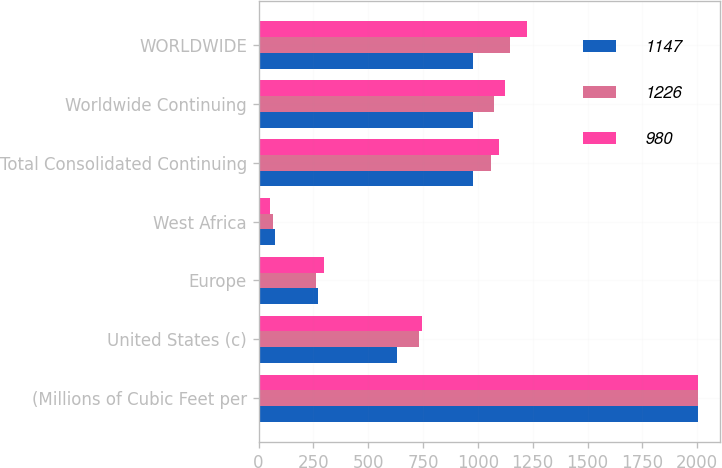<chart> <loc_0><loc_0><loc_500><loc_500><stacked_bar_chart><ecel><fcel>(Millions of Cubic Feet per<fcel>United States (c)<fcel>Europe<fcel>West Africa<fcel>Total Consolidated Continuing<fcel>Worldwide Continuing<fcel>WORLDWIDE<nl><fcel>1147<fcel>2004<fcel>631<fcel>273<fcel>76<fcel>980<fcel>980<fcel>980<nl><fcel>1226<fcel>2003<fcel>732<fcel>262<fcel>66<fcel>1060<fcel>1073<fcel>1147<nl><fcel>980<fcel>2002<fcel>745<fcel>299<fcel>53<fcel>1097<fcel>1122<fcel>1226<nl></chart> 